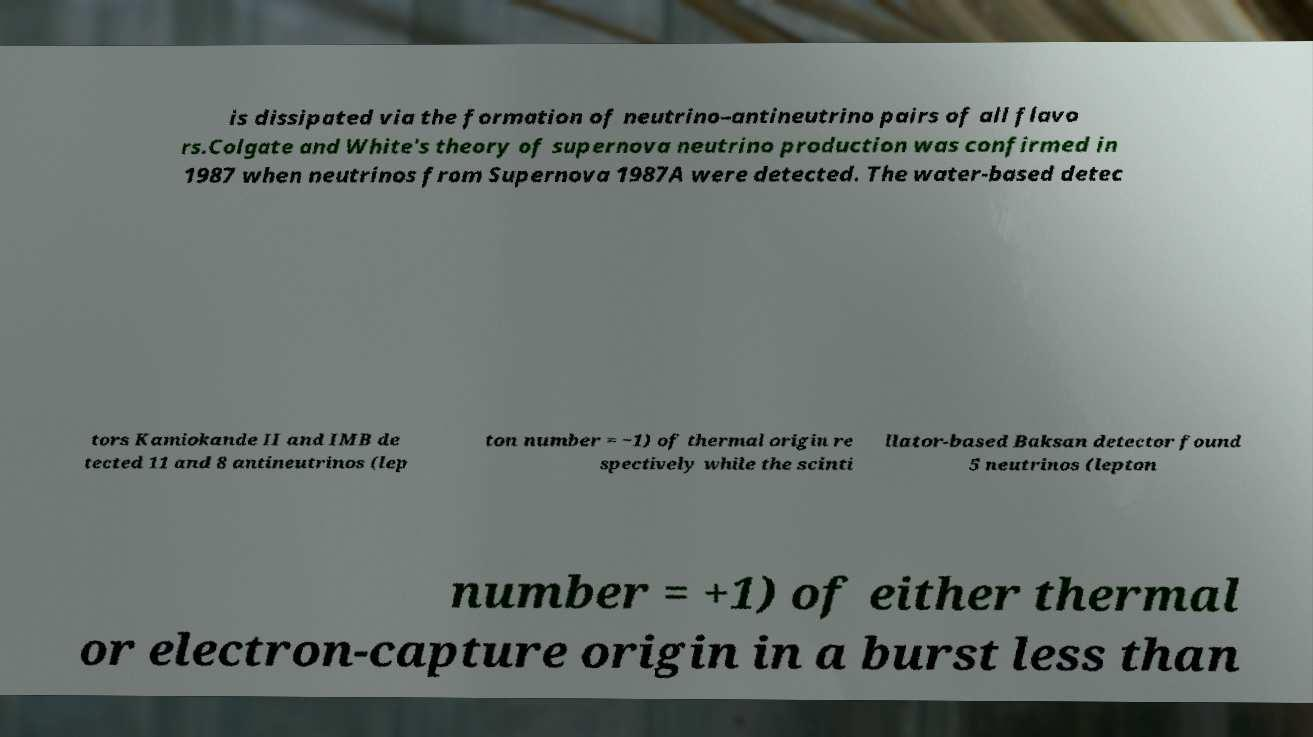Please identify and transcribe the text found in this image. is dissipated via the formation of neutrino–antineutrino pairs of all flavo rs.Colgate and White's theory of supernova neutrino production was confirmed in 1987 when neutrinos from Supernova 1987A were detected. The water-based detec tors Kamiokande II and IMB de tected 11 and 8 antineutrinos (lep ton number = −1) of thermal origin re spectively while the scinti llator-based Baksan detector found 5 neutrinos (lepton number = +1) of either thermal or electron-capture origin in a burst less than 